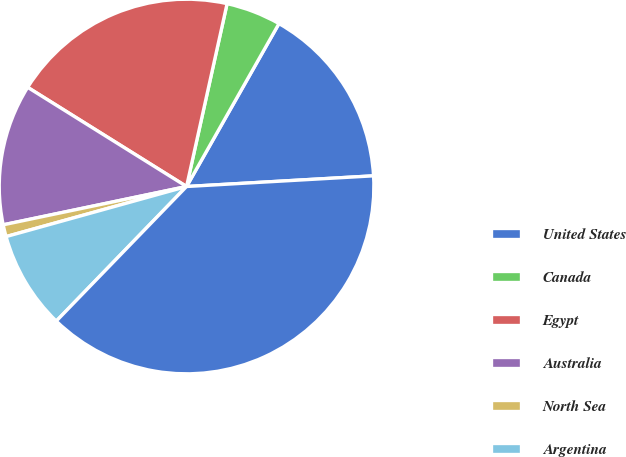Convert chart to OTSL. <chart><loc_0><loc_0><loc_500><loc_500><pie_chart><fcel>United States<fcel>Canada<fcel>Egypt<fcel>Australia<fcel>North Sea<fcel>Argentina<fcel>Total<nl><fcel>15.88%<fcel>4.74%<fcel>19.59%<fcel>12.16%<fcel>1.03%<fcel>8.45%<fcel>38.15%<nl></chart> 